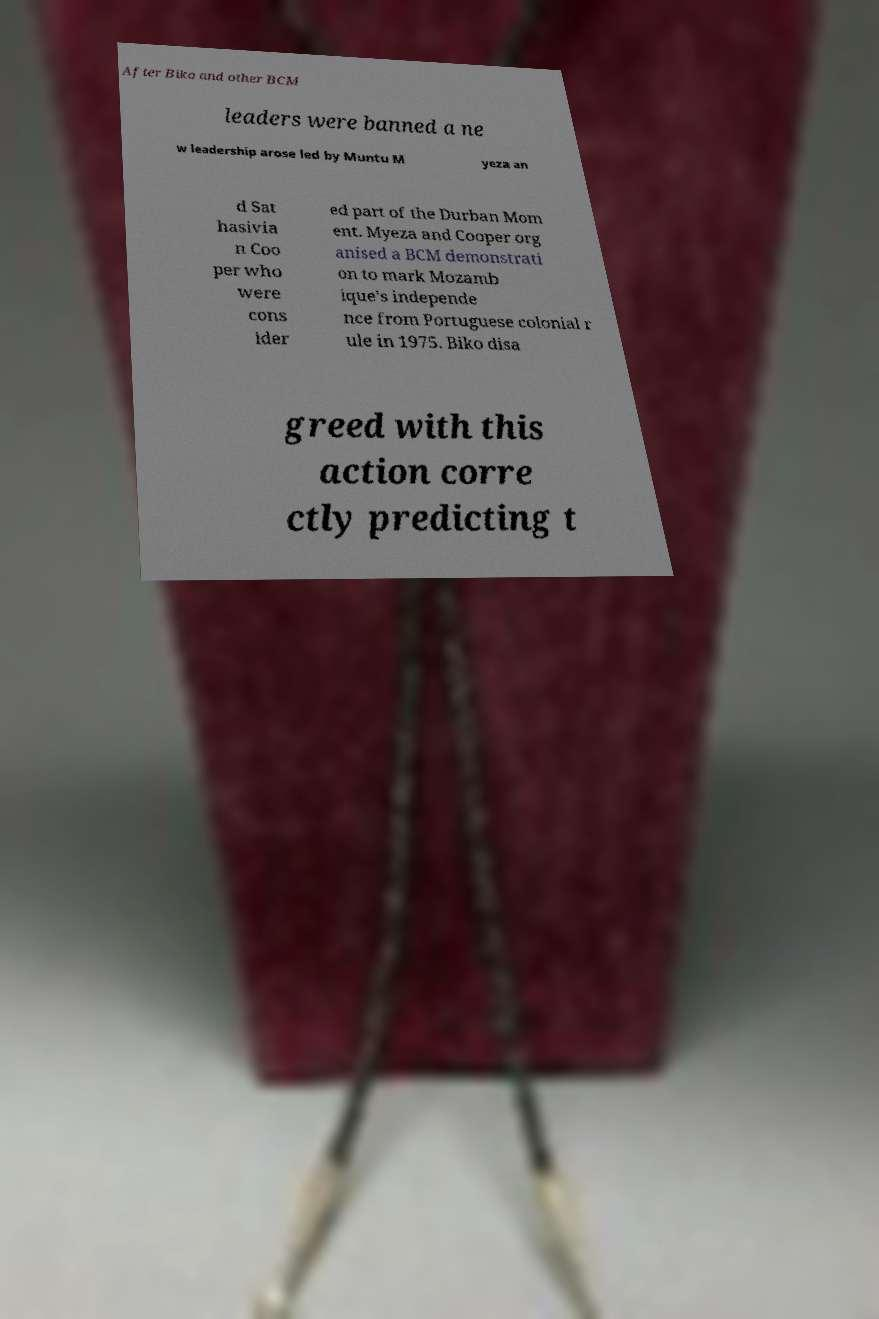There's text embedded in this image that I need extracted. Can you transcribe it verbatim? After Biko and other BCM leaders were banned a ne w leadership arose led by Muntu M yeza an d Sat hasivia n Coo per who were cons ider ed part of the Durban Mom ent. Myeza and Cooper org anised a BCM demonstrati on to mark Mozamb ique's independe nce from Portuguese colonial r ule in 1975. Biko disa greed with this action corre ctly predicting t 